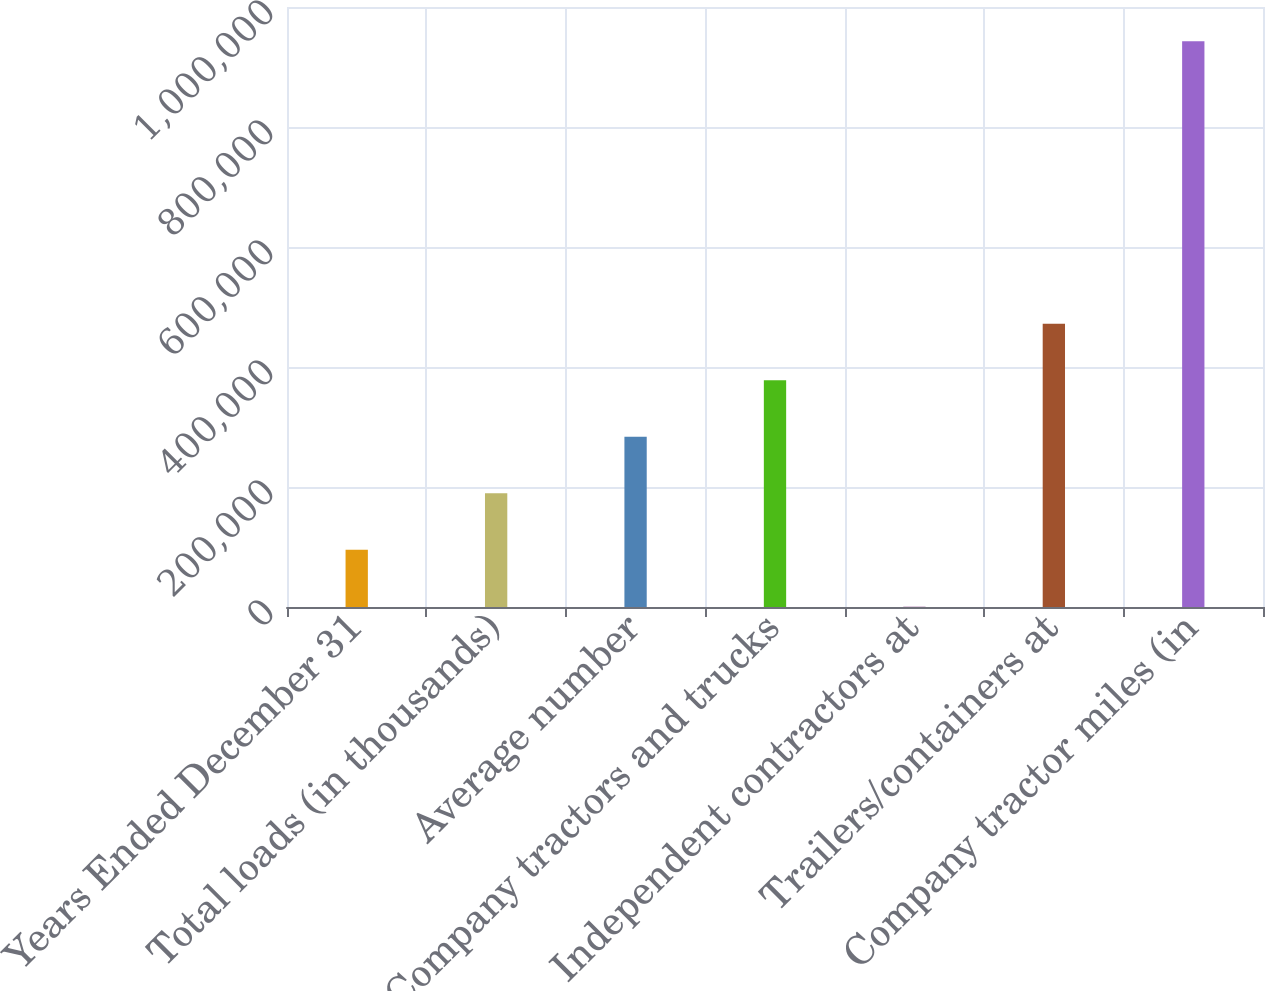<chart> <loc_0><loc_0><loc_500><loc_500><bar_chart><fcel>Years Ended December 31<fcel>Total loads (in thousands)<fcel>Average number<fcel>Company tractors and trucks<fcel>Independent contractors at<fcel>Trailers/containers at<fcel>Company tractor miles (in<nl><fcel>95477.3<fcel>189654<fcel>283830<fcel>378006<fcel>1301<fcel>472182<fcel>943064<nl></chart> 